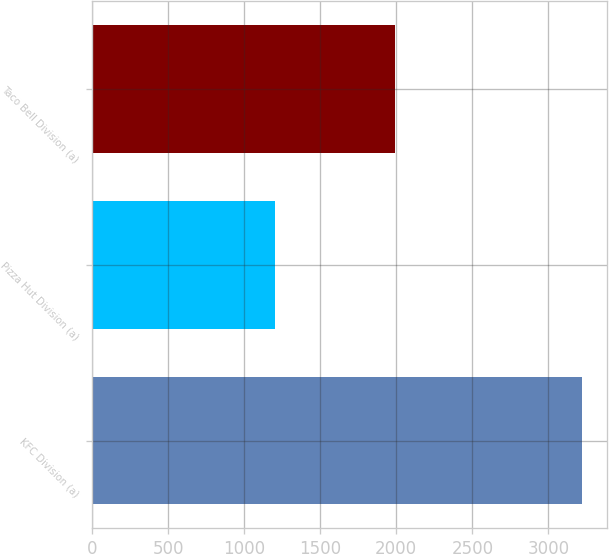Convert chart. <chart><loc_0><loc_0><loc_500><loc_500><bar_chart><fcel>KFC Division (a)<fcel>Pizza Hut Division (a)<fcel>Taco Bell Division (a)<nl><fcel>3222<fcel>1205<fcel>1991<nl></chart> 